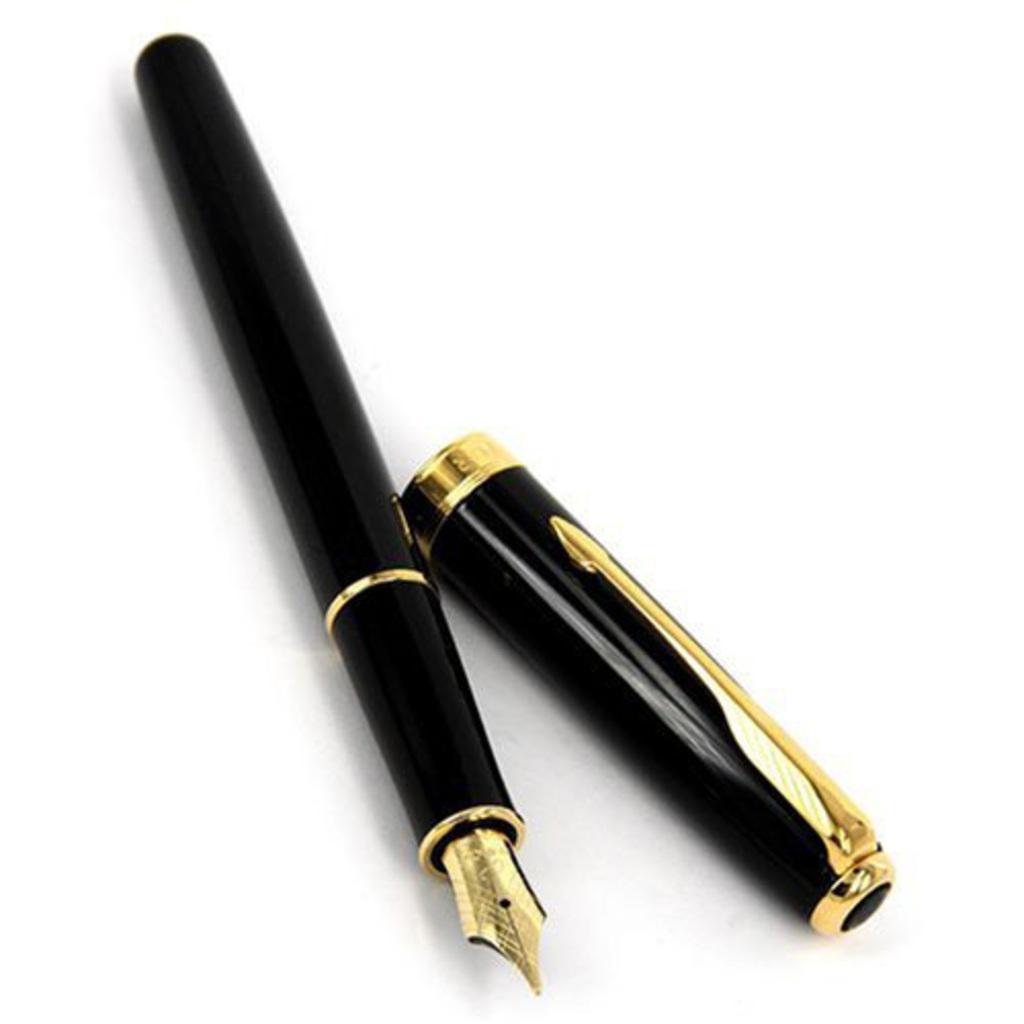Can you describe this image briefly? In this image we can see a pen which is black and gold in color. 